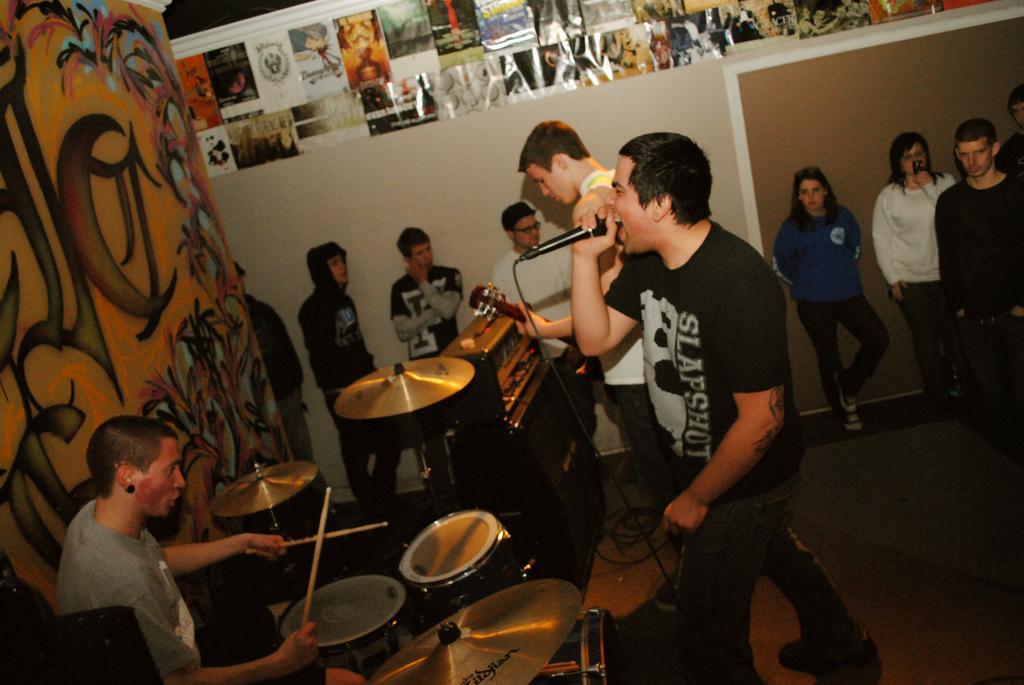Please provide a concise description of this image. In the center of the image two persons are standing, one person is holding a mic and another person is holding a guitar. On the left side of the image a person is sitting and playing drums. On the left side of the image wall is there. On the wall a graffiti is present. In the center of the image some persons are there. At the bottom of the image floor is there. At the top of the image poster is present. 